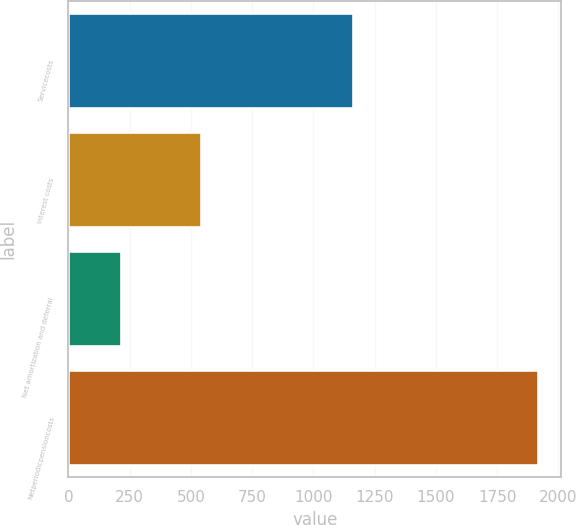Convert chart to OTSL. <chart><loc_0><loc_0><loc_500><loc_500><bar_chart><fcel>Servicecosts<fcel>Interest costs<fcel>Net amortization and deferral<fcel>Netperiodicpensioncosts<nl><fcel>1160<fcel>539<fcel>216<fcel>1915<nl></chart> 